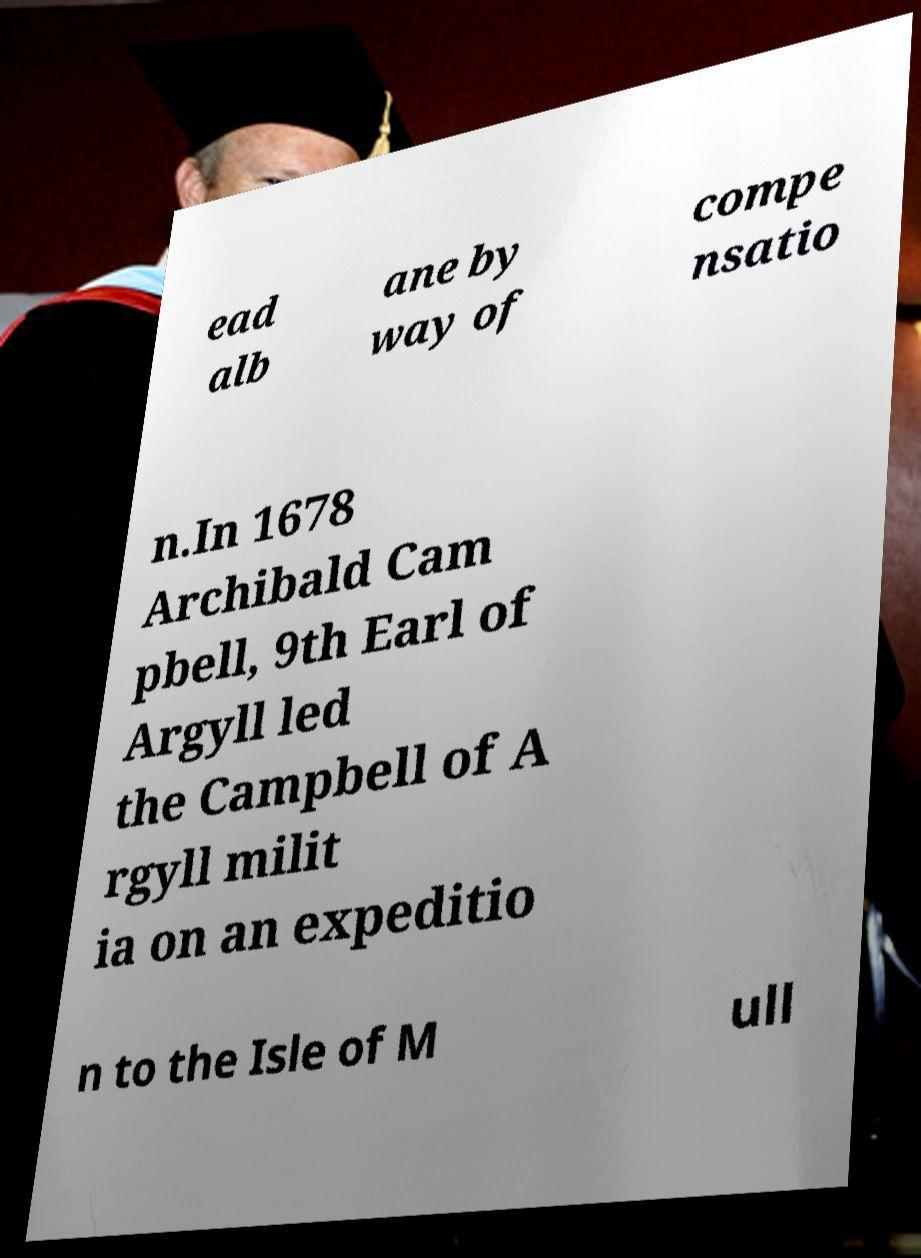Please identify and transcribe the text found in this image. ead alb ane by way of compe nsatio n.In 1678 Archibald Cam pbell, 9th Earl of Argyll led the Campbell of A rgyll milit ia on an expeditio n to the Isle of M ull 